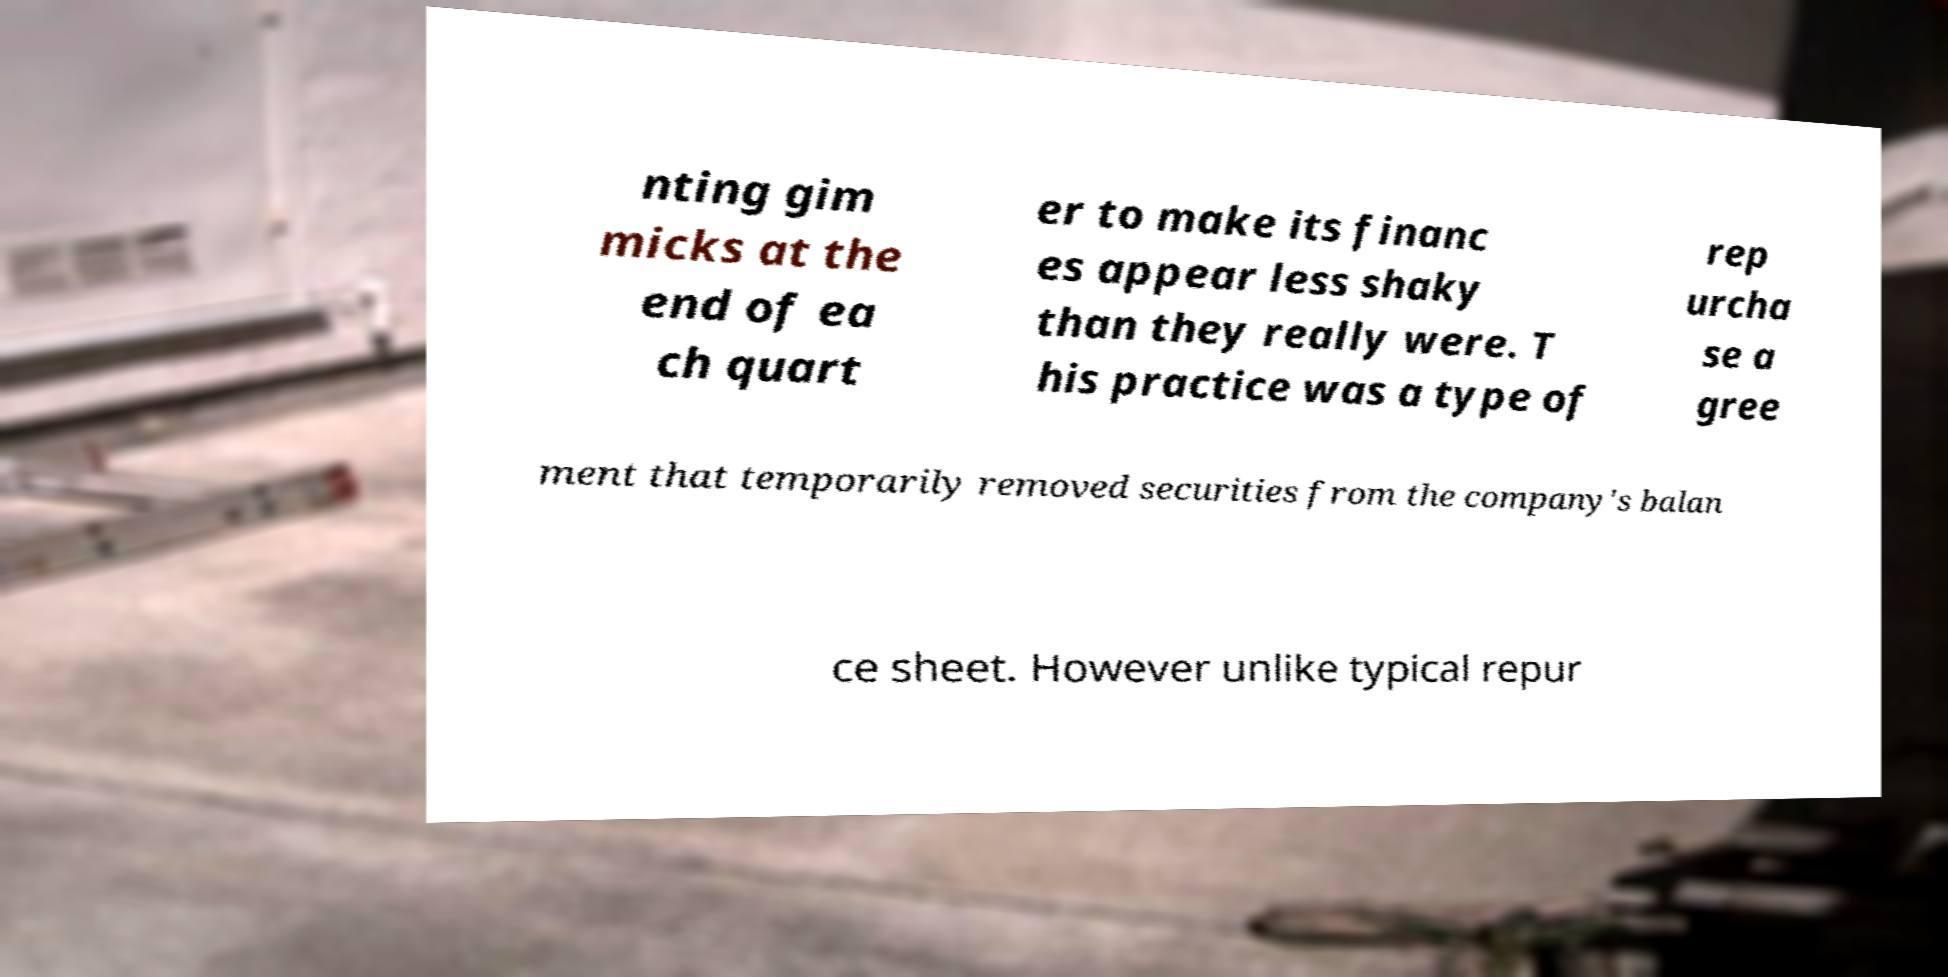Please read and relay the text visible in this image. What does it say? nting gim micks at the end of ea ch quart er to make its financ es appear less shaky than they really were. T his practice was a type of rep urcha se a gree ment that temporarily removed securities from the company's balan ce sheet. However unlike typical repur 